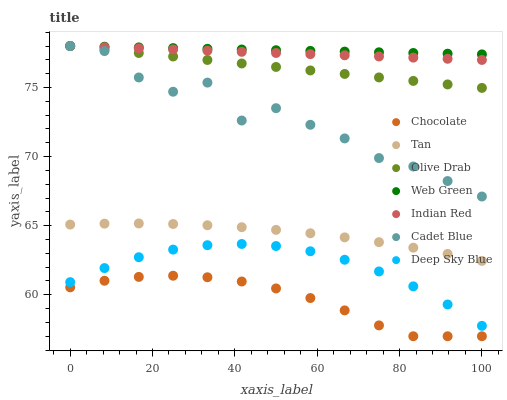Does Chocolate have the minimum area under the curve?
Answer yes or no. Yes. Does Web Green have the maximum area under the curve?
Answer yes or no. Yes. Does Deep Sky Blue have the minimum area under the curve?
Answer yes or no. No. Does Deep Sky Blue have the maximum area under the curve?
Answer yes or no. No. Is Indian Red the smoothest?
Answer yes or no. Yes. Is Cadet Blue the roughest?
Answer yes or no. Yes. Is Deep Sky Blue the smoothest?
Answer yes or no. No. Is Deep Sky Blue the roughest?
Answer yes or no. No. Does Chocolate have the lowest value?
Answer yes or no. Yes. Does Deep Sky Blue have the lowest value?
Answer yes or no. No. Does Olive Drab have the highest value?
Answer yes or no. Yes. Does Deep Sky Blue have the highest value?
Answer yes or no. No. Is Deep Sky Blue less than Olive Drab?
Answer yes or no. Yes. Is Web Green greater than Deep Sky Blue?
Answer yes or no. Yes. Does Olive Drab intersect Cadet Blue?
Answer yes or no. Yes. Is Olive Drab less than Cadet Blue?
Answer yes or no. No. Is Olive Drab greater than Cadet Blue?
Answer yes or no. No. Does Deep Sky Blue intersect Olive Drab?
Answer yes or no. No. 